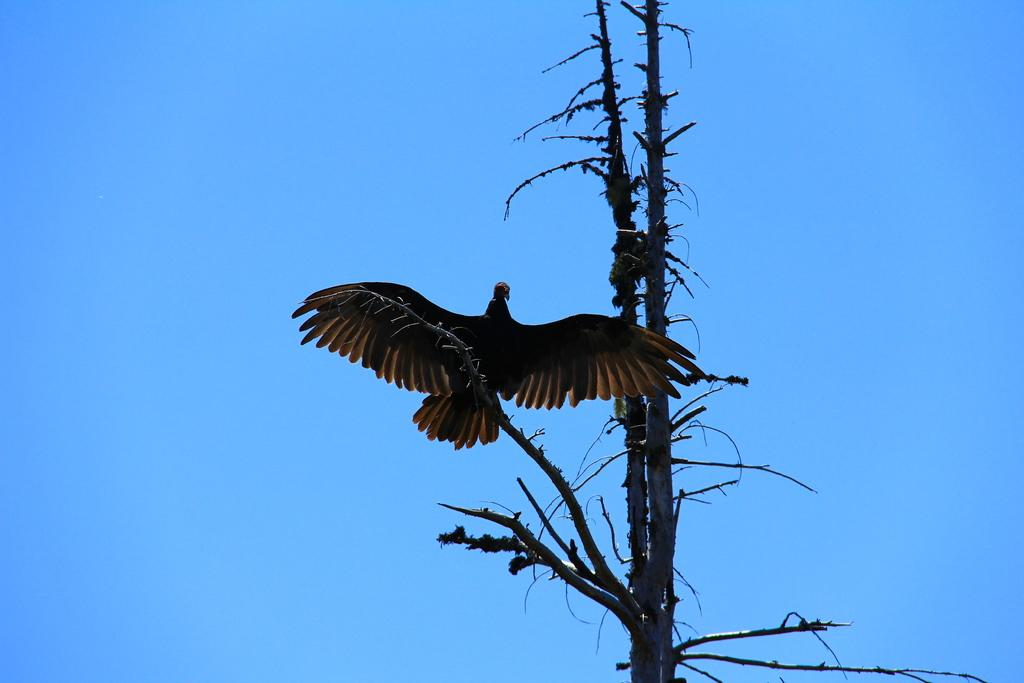What is the main subject in the foreground of the image? There is a bird in the foreground of the image. Where is the bird located? The bird is on a tree. What can be seen in the background of the image? The sky is visible in the background of the image. What type of wood is the hen using to build its nest in the image? There is no hen or nest present in the image; it features a bird on a tree with the sky visible in the background. 